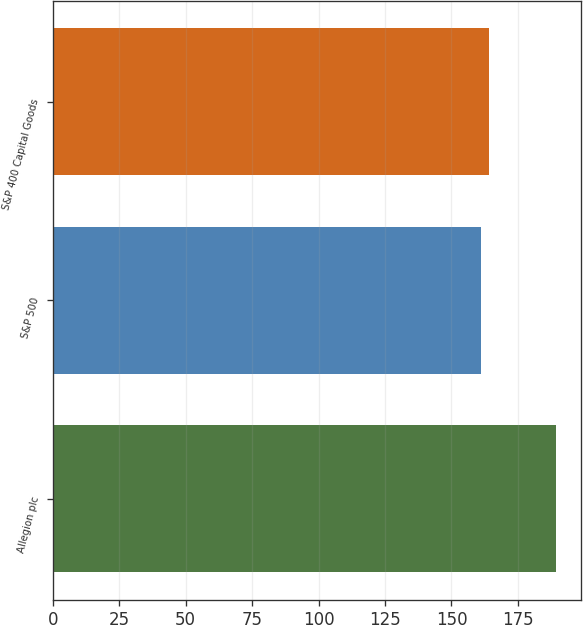Convert chart to OTSL. <chart><loc_0><loc_0><loc_500><loc_500><bar_chart><fcel>Allegion plc<fcel>S&P 500<fcel>S&P 400 Capital Goods<nl><fcel>189.19<fcel>161.2<fcel>164<nl></chart> 